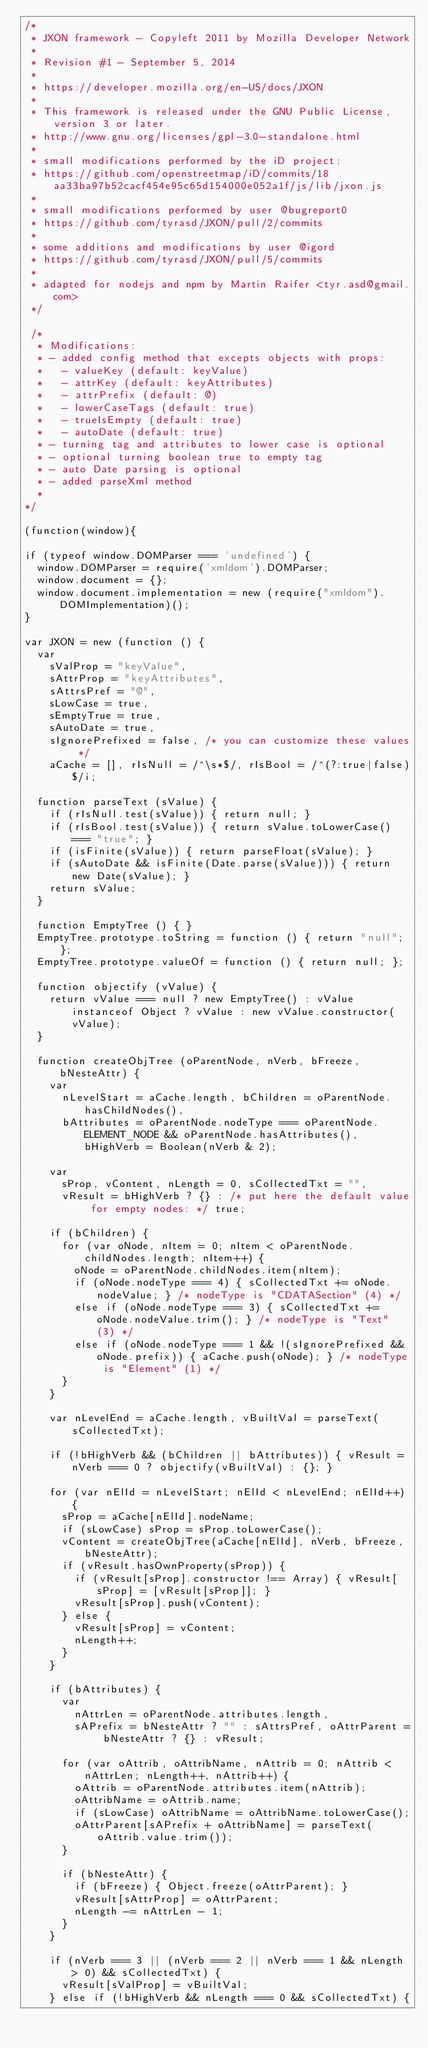<code> <loc_0><loc_0><loc_500><loc_500><_JavaScript_>/*
 * JXON framework - Copyleft 2011 by Mozilla Developer Network
 *
 * Revision #1 - September 5, 2014
 *
 * https://developer.mozilla.org/en-US/docs/JXON
 *
 * This framework is released under the GNU Public License, version 3 or later.
 * http://www.gnu.org/licenses/gpl-3.0-standalone.html
 *
 * small modifications performed by the iD project:
 * https://github.com/openstreetmap/iD/commits/18aa33ba97b52cacf454e95c65d154000e052a1f/js/lib/jxon.js
 *
 * small modifications performed by user @bugreport0
 * https://github.com/tyrasd/JXON/pull/2/commits
 *
 * some additions and modifications by user @igord
 * https://github.com/tyrasd/JXON/pull/5/commits
 *
 * adapted for nodejs and npm by Martin Raifer <tyr.asd@gmail.com>
 */

 /*
  * Modifications:
  * - added config method that excepts objects with props:
  *   - valueKey (default: keyValue)
  *   - attrKey (default: keyAttributes)
  *   - attrPrefix (default: @)
  *   - lowerCaseTags (default: true)
  *   - trueIsEmpty (default: true)
  *   - autoDate (default: true)
  * - turning tag and attributes to lower case is optional
  * - optional turning boolean true to empty tag
  * - auto Date parsing is optional
  * - added parseXml method
  *
*/

(function(window){

if (typeof window.DOMParser === 'undefined') {
  window.DOMParser = require('xmldom').DOMParser;
  window.document = {};
  window.document.implementation = new (require("xmldom").DOMImplementation)();
}

var JXON = new (function () {
  var
    sValProp = "keyValue", 
    sAttrProp = "keyAttributes", 
    sAttrsPref = "@", 
    sLowCase = true, 
    sEmptyTrue = true,
    sAutoDate = true,
    sIgnorePrefixed = false, /* you can customize these values */
    aCache = [], rIsNull = /^\s*$/, rIsBool = /^(?:true|false)$/i;

  function parseText (sValue) {
    if (rIsNull.test(sValue)) { return null; }
    if (rIsBool.test(sValue)) { return sValue.toLowerCase() === "true"; }
    if (isFinite(sValue)) { return parseFloat(sValue); }
    if (sAutoDate && isFinite(Date.parse(sValue))) { return new Date(sValue); }
    return sValue;
  }

  function EmptyTree () { }
  EmptyTree.prototype.toString = function () { return "null"; };
  EmptyTree.prototype.valueOf = function () { return null; };

  function objectify (vValue) {
    return vValue === null ? new EmptyTree() : vValue instanceof Object ? vValue : new vValue.constructor(vValue);
  }

  function createObjTree (oParentNode, nVerb, bFreeze, bNesteAttr) {
    var
      nLevelStart = aCache.length, bChildren = oParentNode.hasChildNodes(),
      bAttributes = oParentNode.nodeType === oParentNode.ELEMENT_NODE && oParentNode.hasAttributes(), bHighVerb = Boolean(nVerb & 2);

    var
      sProp, vContent, nLength = 0, sCollectedTxt = "",
      vResult = bHighVerb ? {} : /* put here the default value for empty nodes: */ true;

    if (bChildren) {
      for (var oNode, nItem = 0; nItem < oParentNode.childNodes.length; nItem++) {
        oNode = oParentNode.childNodes.item(nItem);
        if (oNode.nodeType === 4) { sCollectedTxt += oNode.nodeValue; } /* nodeType is "CDATASection" (4) */
        else if (oNode.nodeType === 3) { sCollectedTxt += oNode.nodeValue.trim(); } /* nodeType is "Text" (3) */
        else if (oNode.nodeType === 1 && !(sIgnorePrefixed && oNode.prefix)) { aCache.push(oNode); } /* nodeType is "Element" (1) */
      }
    }

    var nLevelEnd = aCache.length, vBuiltVal = parseText(sCollectedTxt);

    if (!bHighVerb && (bChildren || bAttributes)) { vResult = nVerb === 0 ? objectify(vBuiltVal) : {}; }

    for (var nElId = nLevelStart; nElId < nLevelEnd; nElId++) {
      sProp = aCache[nElId].nodeName;
      if (sLowCase) sProp = sProp.toLowerCase();
      vContent = createObjTree(aCache[nElId], nVerb, bFreeze, bNesteAttr);
      if (vResult.hasOwnProperty(sProp)) {
        if (vResult[sProp].constructor !== Array) { vResult[sProp] = [vResult[sProp]]; }
        vResult[sProp].push(vContent);
      } else {
        vResult[sProp] = vContent;
        nLength++;
      }
    }

    if (bAttributes) {
      var
        nAttrLen = oParentNode.attributes.length,
        sAPrefix = bNesteAttr ? "" : sAttrsPref, oAttrParent = bNesteAttr ? {} : vResult;

      for (var oAttrib, oAttribName, nAttrib = 0; nAttrib < nAttrLen; nLength++, nAttrib++) {
        oAttrib = oParentNode.attributes.item(nAttrib);
        oAttribName = oAttrib.name;
        if (sLowCase) oAttribName = oAttribName.toLowerCase();
        oAttrParent[sAPrefix + oAttribName] = parseText(oAttrib.value.trim());
      }

      if (bNesteAttr) {
        if (bFreeze) { Object.freeze(oAttrParent); }
        vResult[sAttrProp] = oAttrParent;
        nLength -= nAttrLen - 1;
      }
    }

    if (nVerb === 3 || (nVerb === 2 || nVerb === 1 && nLength > 0) && sCollectedTxt) {
      vResult[sValProp] = vBuiltVal;
    } else if (!bHighVerb && nLength === 0 && sCollectedTxt) {</code> 